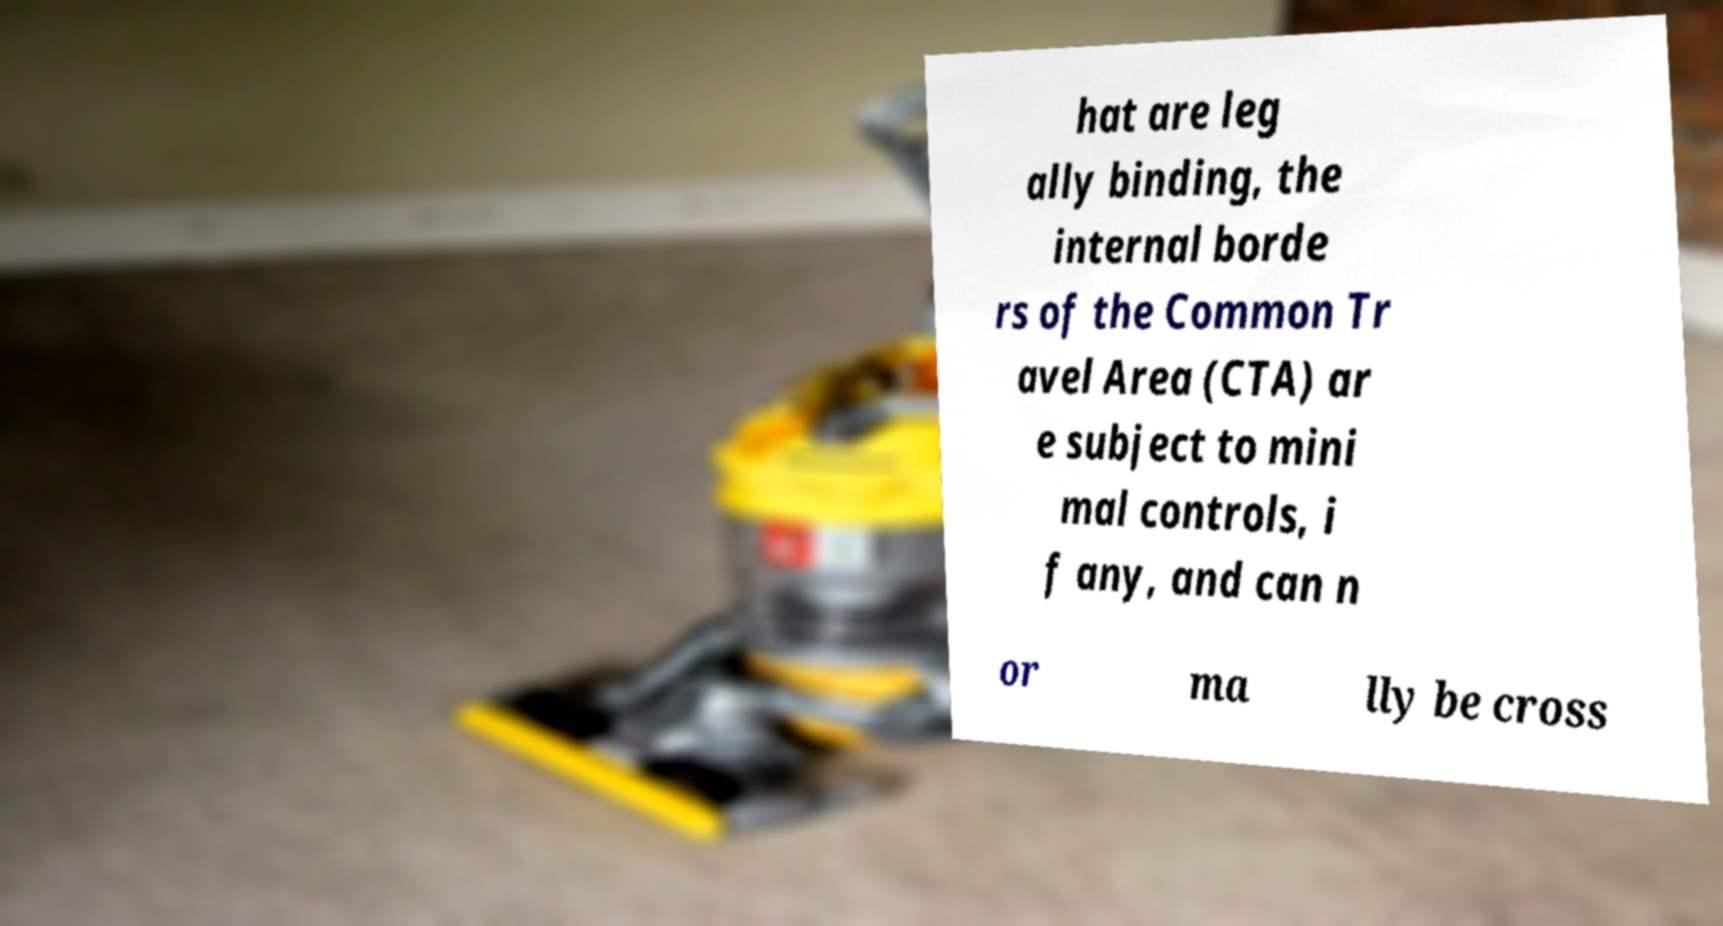Please read and relay the text visible in this image. What does it say? hat are leg ally binding, the internal borde rs of the Common Tr avel Area (CTA) ar e subject to mini mal controls, i f any, and can n or ma lly be cross 